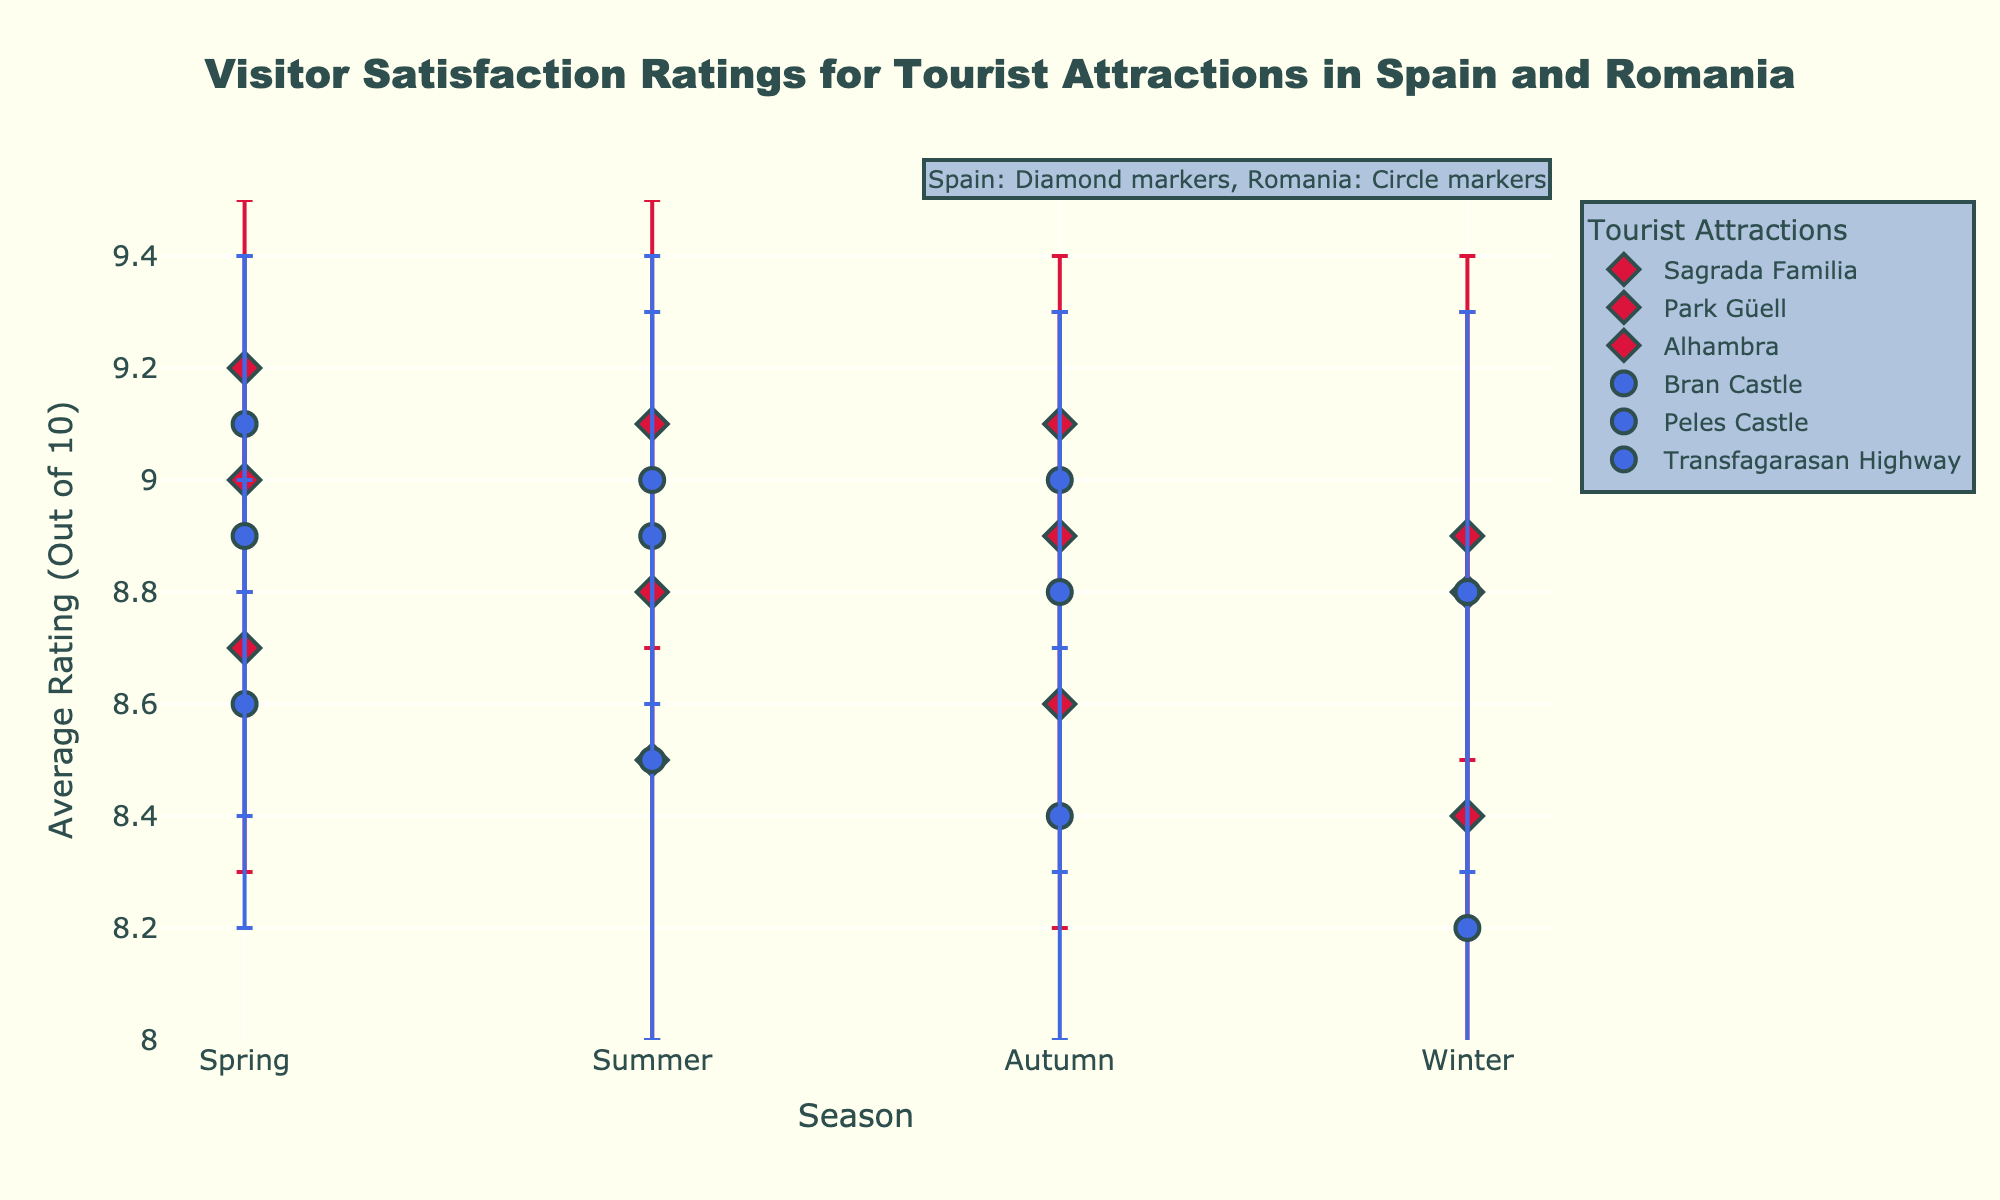What is the title of the figure? The title is at the top of the figure and reads: "Visitor Satisfaction Ratings for Tourist Attractions in Spain and Romania".
Answer: Visitor Satisfaction Ratings for Tourist Attractions in Spain and Romania How are the markers visually distinguished between attractions in Spain and Romania? Spain's markers are diamond-shaped and colored in Crimson, while Romania's markers are circle-shaped and colored in RoyalBlue. This is also noted in an annotation at the top right of the figure.
Answer: Spain: Diamond, Crimson; Romania: Circle, RoyalBlue What is the highest average rating recorded for any tourist attraction, and which attraction and season does it belong to? The highest average rating observed is 9.2 for Sagrada Familia in Spain during the Spring season.
Answer: 9.2, Sagrada Familia, Spring Which attraction in Romania shows the greatest variability in ratings, and during which season? The variability is indicated by the length of the error bars. Bran Castle in Romania shows the greatest variability in the Winter season with a standard deviation of 0.6.
Answer: Bran Castle, Winter Comparing the summer ratings of Alhambra (Spain) and Peles Castle (Romania), which one has a higher rating? Look at the markers for Alhambra and Peles Castle during the Summer season. Alhambra has a rating of 8.8 while Peles Castle has a rating of 8.9.
Answer: Peles Castle What is the average rating for Park Güell in Autumn and Winter? Park Güell's Autumn rating is 8.6 and Winter rating is 8.4, calculate the average ((8.6 + 8.4) / 2).
Answer: 8.5 Which tourist attraction in Spain has the lowest recorded rating, and during which season? Sagrada Familia has the lowest recorded rating of 8.8 during the Winter season.
Answer: Sagrada Familia, Winter What is the rating difference between Transfagarasan Highway in Summer and Autumn? Transfagarasan Highway has a rating of 9.0 in Summer and 8.8 in Autumn. The difference is 9.0 - 8.8.
Answer: 0.2 How does the rating for Alhambra change from Spring to Autumn? Observe the average ratings for Alhambra in Spring (9.0) and Autumn (9.1). The rating increases by 0.1.
Answer: Increase by 0.1 